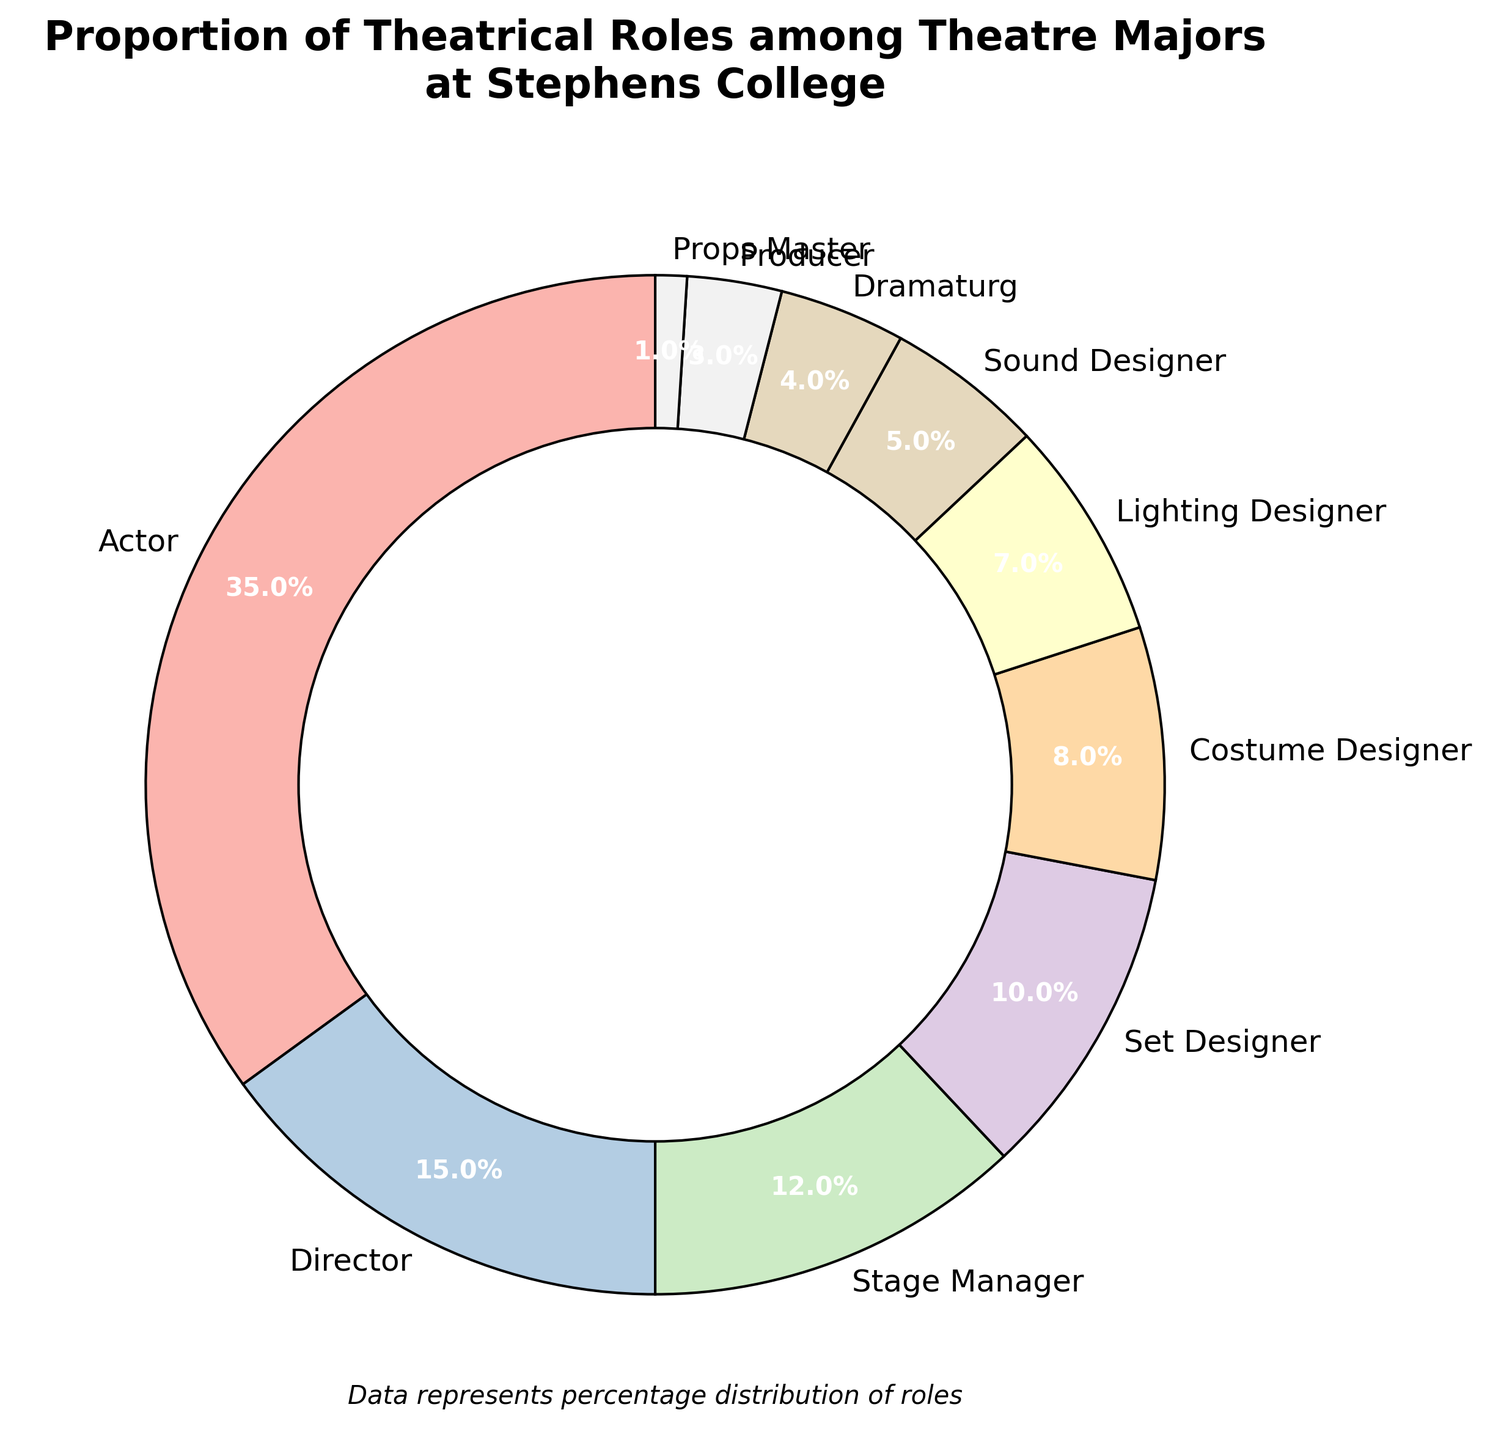What is the percentage of Theatre majors that are actors? The section labeled "Actor" in the pie chart has an autopct value indicating 35%.
Answer: 35% How many roles have a percentage lower than 10%? By looking at the pie chart's labels, we see that Costume Designer (8%), Lighting Designer (7%), Sound Designer (5%), Dramaturg (4%), Producer (3%), and Props Master (1%) all have percentages lower than 10%. There are 6 such roles.
Answer: 6 Which role has the smallest proportion among Theatre majors? The smallest percentage label on the pie chart corresponds to the "Props Master" role, which has a percentage of 1%.
Answer: Props Master What is the combined percentage of Directors and Stage Managers? The percentage for Directors is 15% and for Stage Managers is 12%. Adding these two percentages together, 15% + 12% = 27%.
Answer: 27% Are there more Lighting Designers or Sound Designers among Theatre majors? The pie chart shows Lighting Designers at 7% and Sound Designers at 5%. Since 7% is greater than 5%, there are more Lighting Designers than Sound Designers.
Answer: Lighting Designers What is the difference in percentage between Actors and Directors? The percentage for Actors is 35%, and for Directors it is 15%. The difference is calculated as 35% - 15% = 20%.
Answer: 20% What visual representation is used to show the data distribution in this chart? The chart uses a donut chart, which is a variation of a pie chart with a circular hole in the center for visual representation.
Answer: Donut chart Considering only Designers (Set, Costume, Lighting, Sound), what is their total percentage? The percentages for Set Designer, Costume Designer, Lighting Designer, and Sound Designer are 10%, 8%, 7%, and 5% respectively. Summing these, 10% + 8% + 7% + 5% = 30%.
Answer: 30% What can be inferred from the size difference between the largest and smallest wedges in the pie chart? The largest wedge represents Actors at 35%, and the smallest wedge represents Props Master at 1%. The substantial difference in size shows that Actors significantly outnumber Props Masters among Theatre majors.
Answer: Actors significantly outnumber Props Masters 